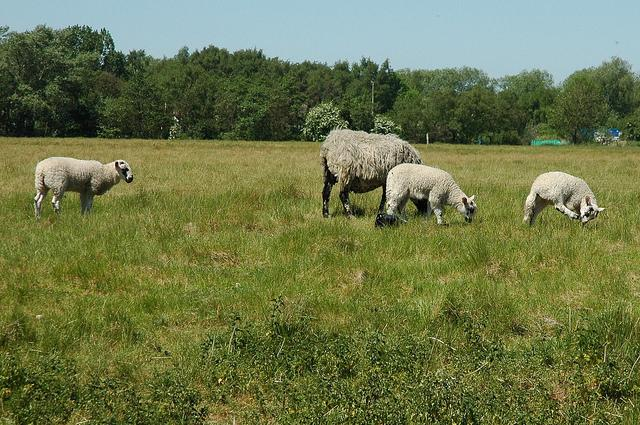What meal would these animals prefer? grass 